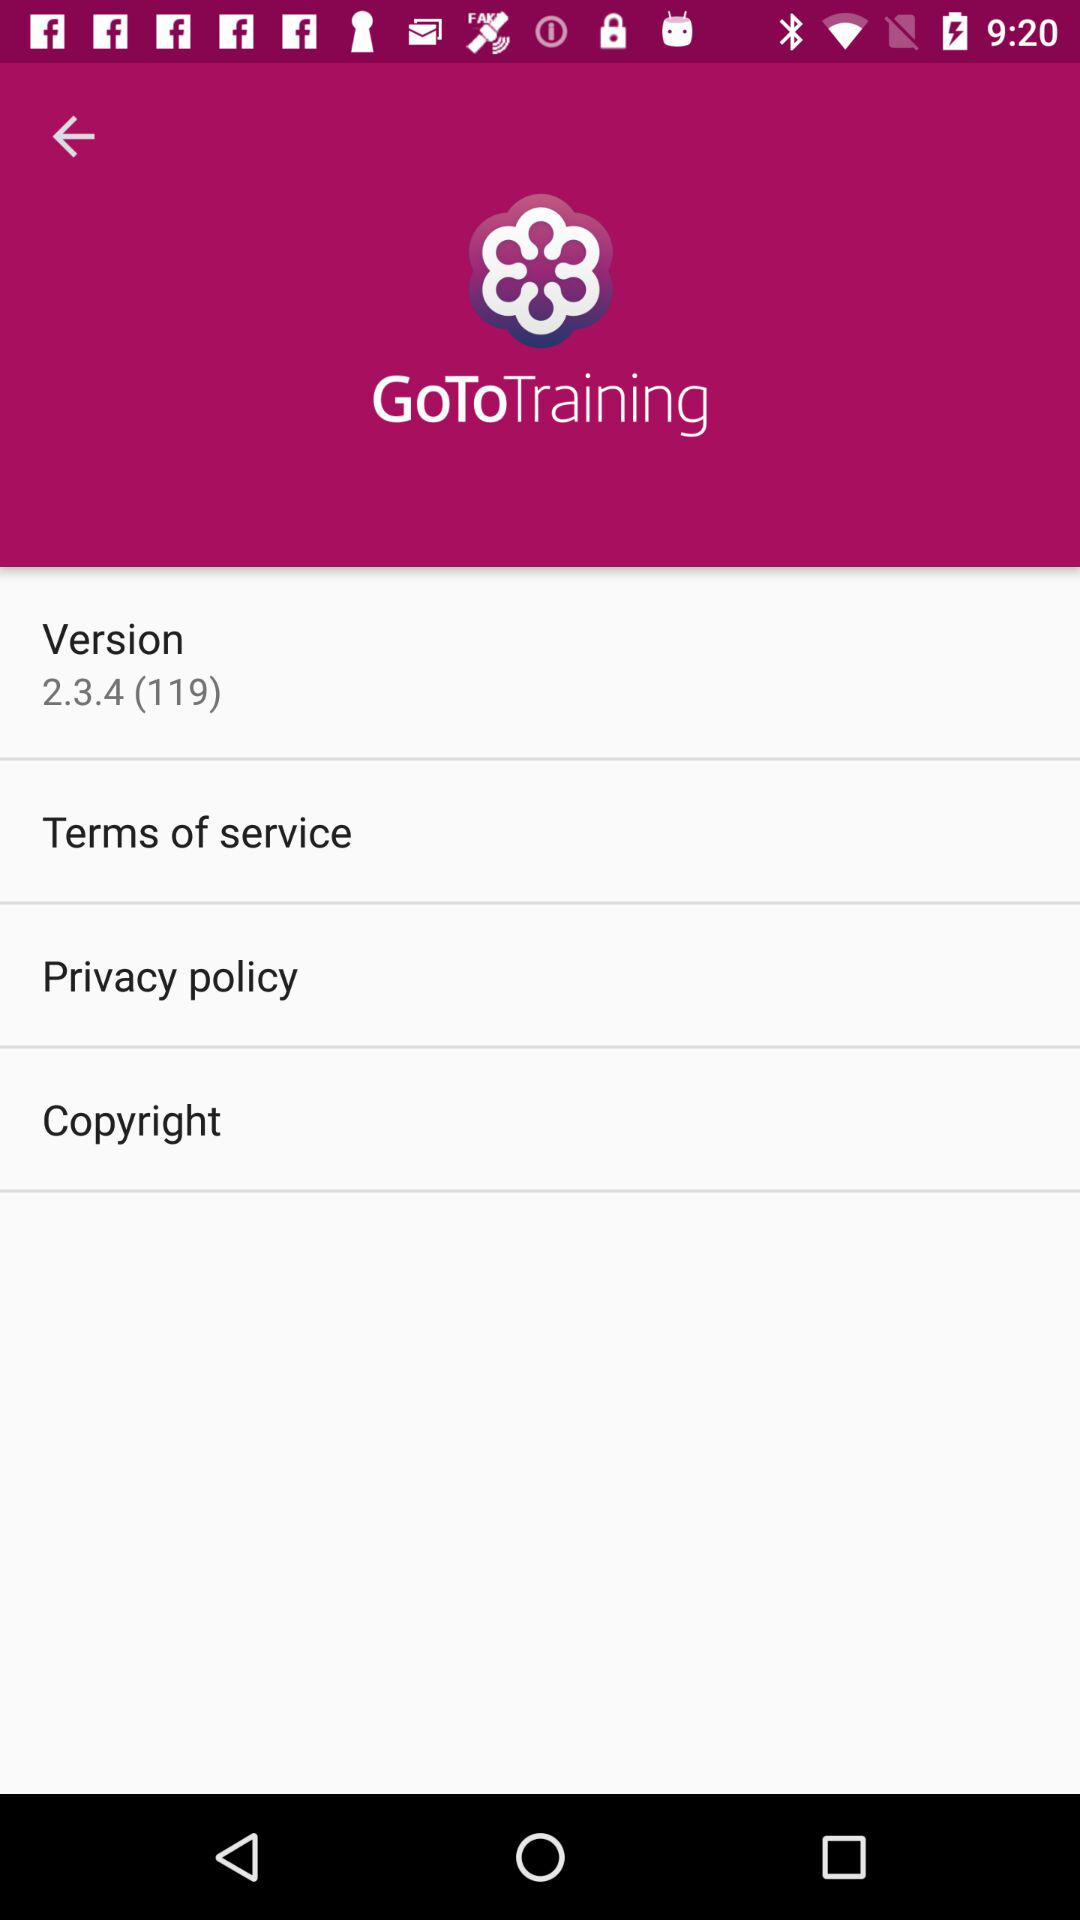What is the version number? The version number is 2.3.4 (119). 